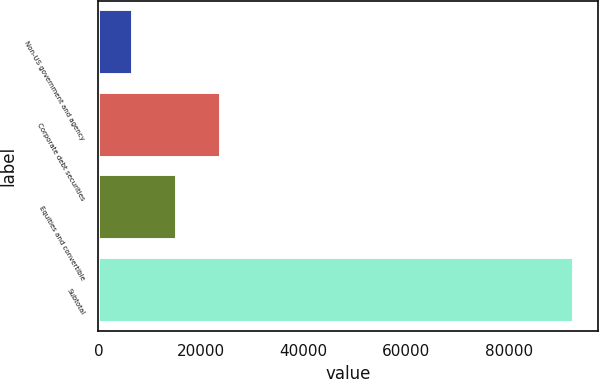Convert chart. <chart><loc_0><loc_0><loc_500><loc_500><bar_chart><fcel>Non-US government and agency<fcel>Corporate debt securities<fcel>Equities and convertible<fcel>Subtotal<nl><fcel>6668<fcel>23874.4<fcel>15271.2<fcel>92700<nl></chart> 